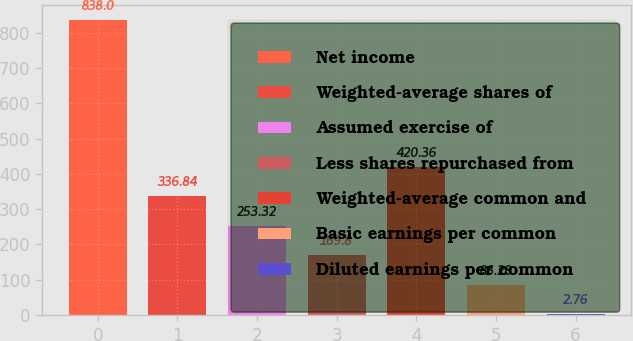<chart> <loc_0><loc_0><loc_500><loc_500><bar_chart><fcel>Net income<fcel>Weighted-average shares of<fcel>Assumed exercise of<fcel>Less shares repurchased from<fcel>Weighted-average common and<fcel>Basic earnings per common<fcel>Diluted earnings per common<nl><fcel>838<fcel>336.84<fcel>253.32<fcel>169.8<fcel>420.36<fcel>86.28<fcel>2.76<nl></chart> 